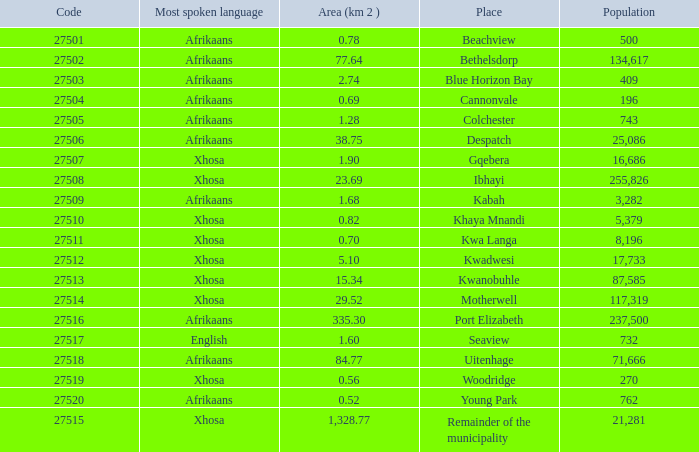What is the lowest area for cannonvale that speaks afrikaans? 0.69. 